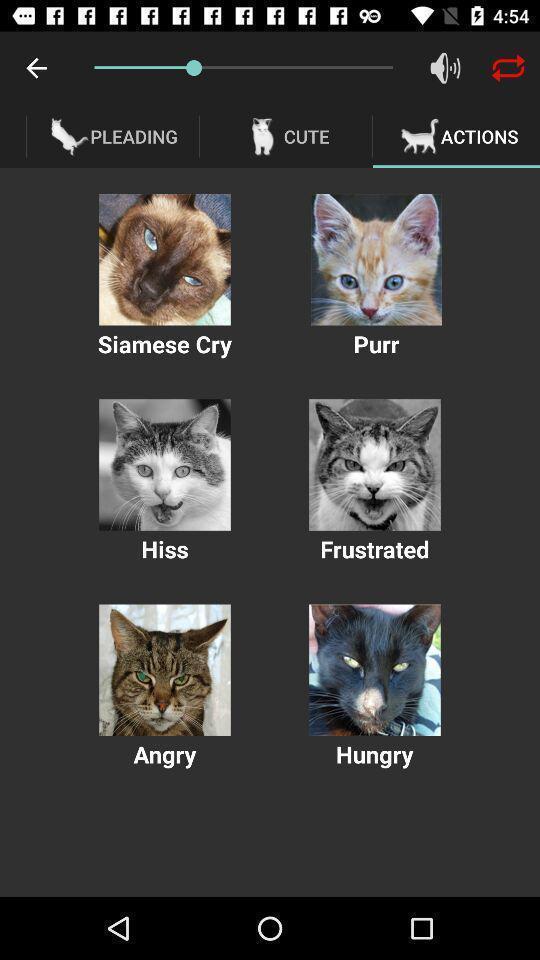Describe this image in words. Screen page displaying various images of cats. 